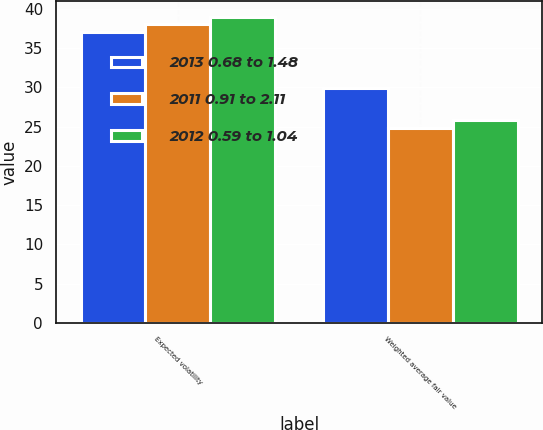<chart> <loc_0><loc_0><loc_500><loc_500><stacked_bar_chart><ecel><fcel>Expected volatility<fcel>Weighted average fair value<nl><fcel>2013 0.68 to 1.48<fcel>37<fcel>29.85<nl><fcel>2011 0.91 to 2.11<fcel>38<fcel>24.82<nl><fcel>2012 0.59 to 1.04<fcel>39<fcel>25.84<nl></chart> 